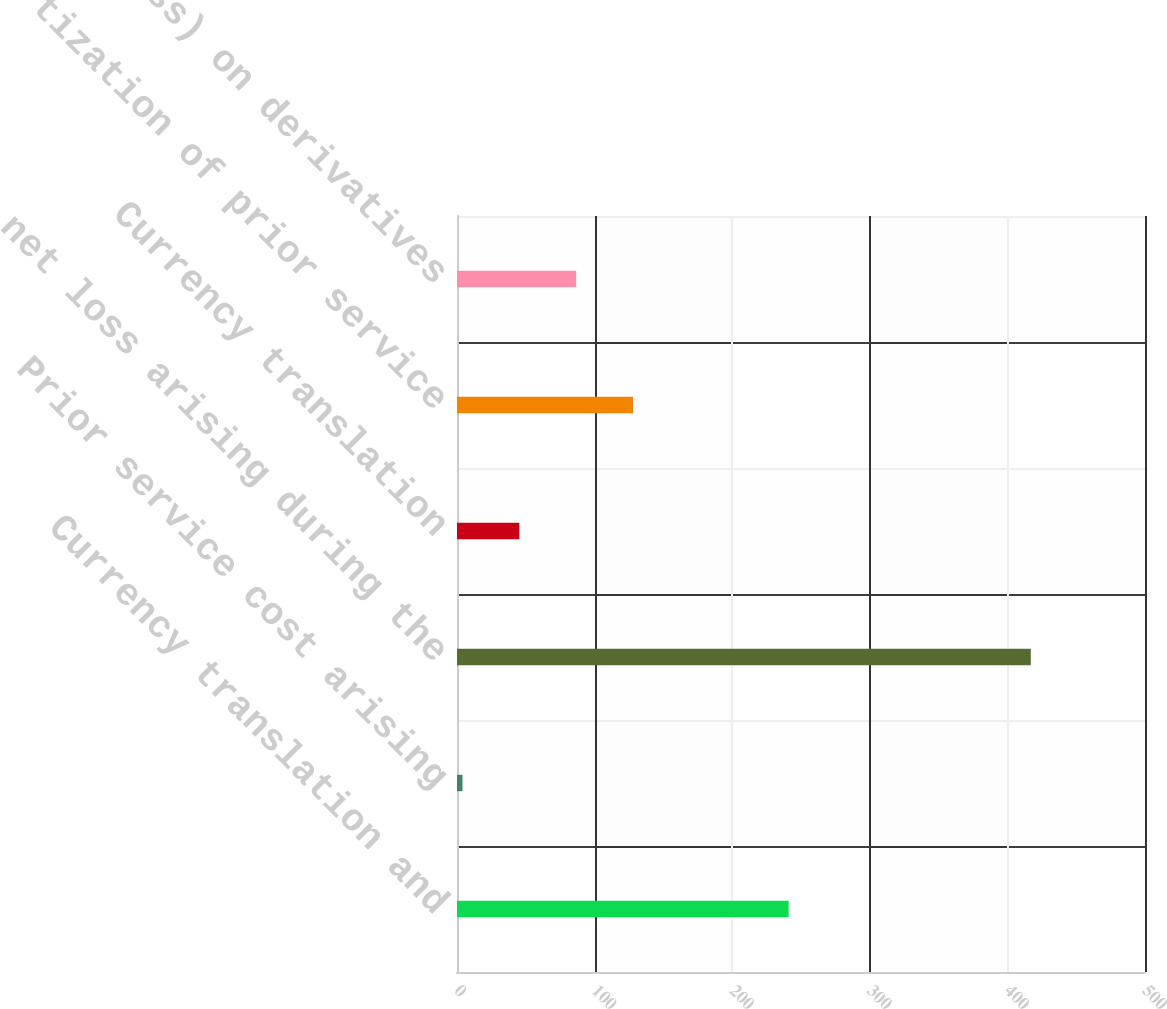<chart> <loc_0><loc_0><loc_500><loc_500><bar_chart><fcel>Currency translation and<fcel>Prior service cost arising<fcel>net loss arising during the<fcel>Currency translation<fcel>Amortization of prior service<fcel>Gain (loss) on derivatives<nl><fcel>241<fcel>4<fcel>417<fcel>45.3<fcel>127.9<fcel>86.6<nl></chart> 